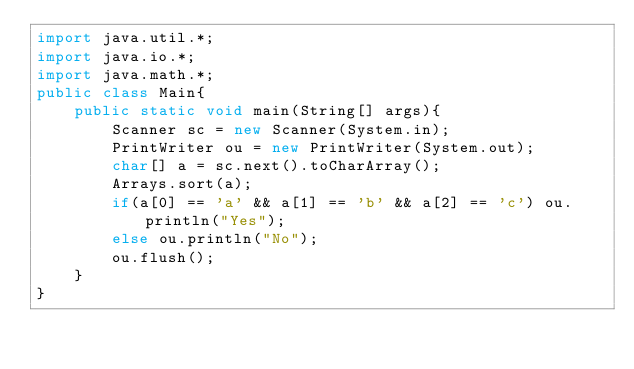Convert code to text. <code><loc_0><loc_0><loc_500><loc_500><_Java_>import java.util.*;
import java.io.*;
import java.math.*;
public class Main{
    public static void main(String[] args){
		Scanner sc = new Scanner(System.in);
		PrintWriter ou = new PrintWriter(System.out);
		char[] a = sc.next().toCharArray();
		Arrays.sort(a);
		if(a[0] == 'a' && a[1] == 'b' && a[2] == 'c') ou.println("Yes");
		else ou.println("No");
		ou.flush();
	}
}</code> 